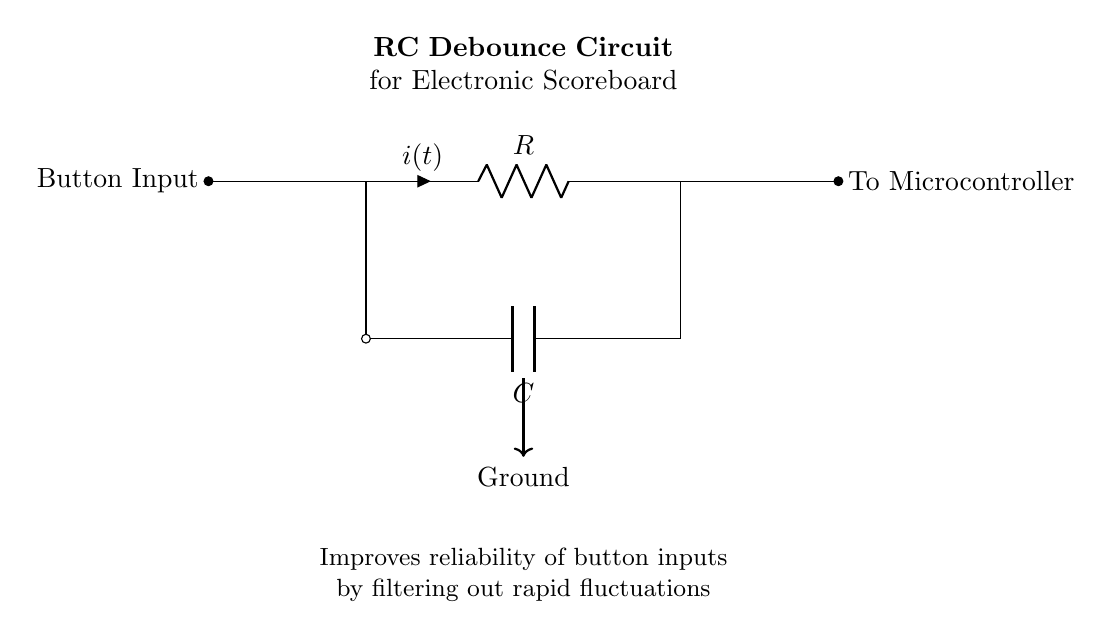What type of circuit is shown? The circuit is an RC debounce circuit, as indicated by the labels in the diagram and the arrangement of the resistor and capacitor components.
Answer: RC debounce circuit What does the resistor in this circuit do? The resistor limits the current flow and, in conjunction with the capacitor, helps to filter out noise from the button press, allowing for a stable input to the microcontroller.
Answer: Limits current What is the role of the capacitor in the circuit? The capacitor stores charge and, together with the resistor, creates a delay in voltage change, helping to smooth out the input signal from the button and debounce it.
Answer: Stores charge How is the button connected in the circuit? The button is connected to the input of the RC circuit, receiving the signal from the user when pressed, which influences the charging of the capacitor.
Answer: In series with the resistor What happens when the button is pressed? When the button is pressed, it causes a change in voltage across the capacitor; however, due to its properties, the voltage doesn't change instantaneously, preventing false triggering of the microcontroller.
Answer: Voltage changes gradually What is the purpose of the ground connection? The ground provides a common reference point for the circuit, completing the electrical circuit and allowing the capacitor to discharge when the button is released.
Answer: Completes circuit What indicates the output of this circuit? The output of this circuit is indicated by the connection to the microcontroller, which receives the debounced signal, ensuring reliable button state detection.
Answer: To microcontroller 